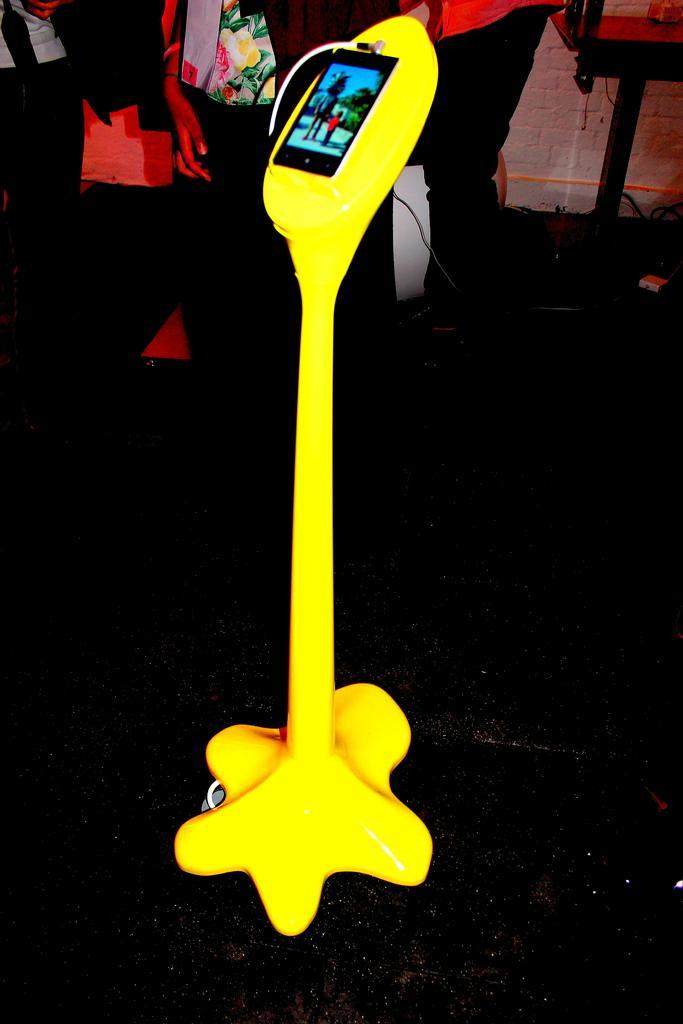In one or two sentences, can you explain what this image depicts? In this image, in the middle, we can see a rod which is in yellow color, in the road, we can see a mobile is attached to it. In the background, we can see a group of people, wall and a table. At the bottom, we can see black color. 